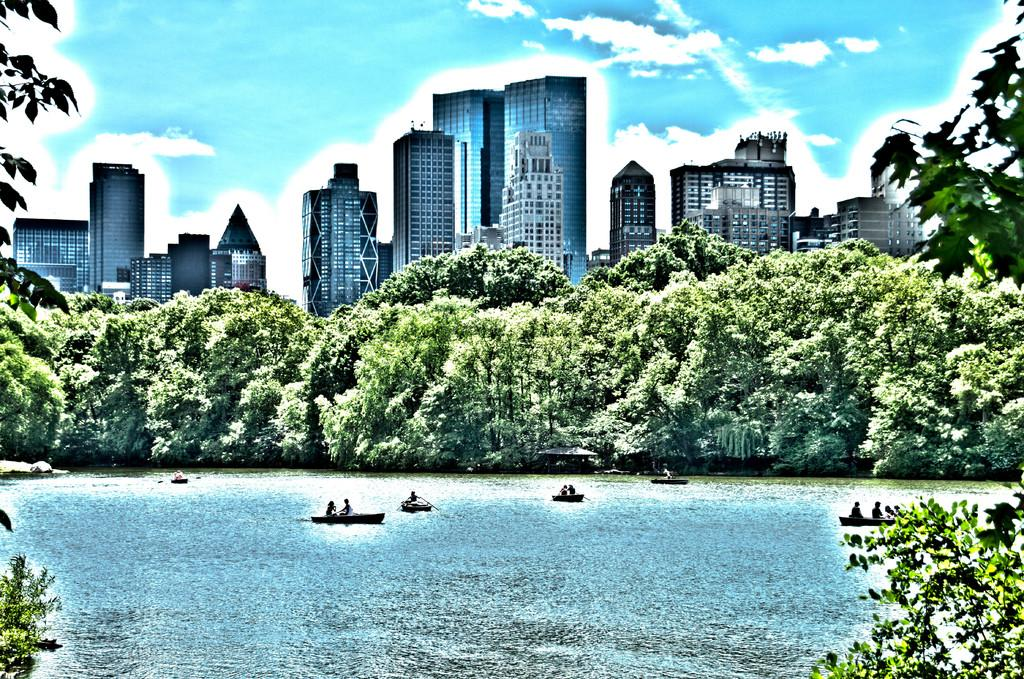What is on the water in the image? There are boats on the water in the image. Who or what is in the boats? There are people in the boats. What can be seen in the background of the image? There are trees, buildings, and the sky visible in the background of the image. What type of fang can be seen in the image? There is no fang present in the image; it features boats on the water with people and a background of trees, buildings, and the sky. 